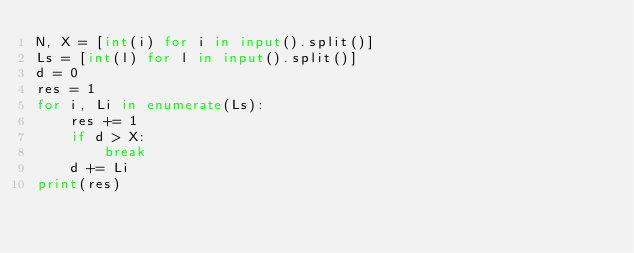<code> <loc_0><loc_0><loc_500><loc_500><_Python_>N, X = [int(i) for i in input().split()]
Ls = [int(l) for l in input().split()]
d = 0
res = 1
for i, Li in enumerate(Ls):
    res += 1
    if d > X:
        break
    d += Li
print(res)</code> 